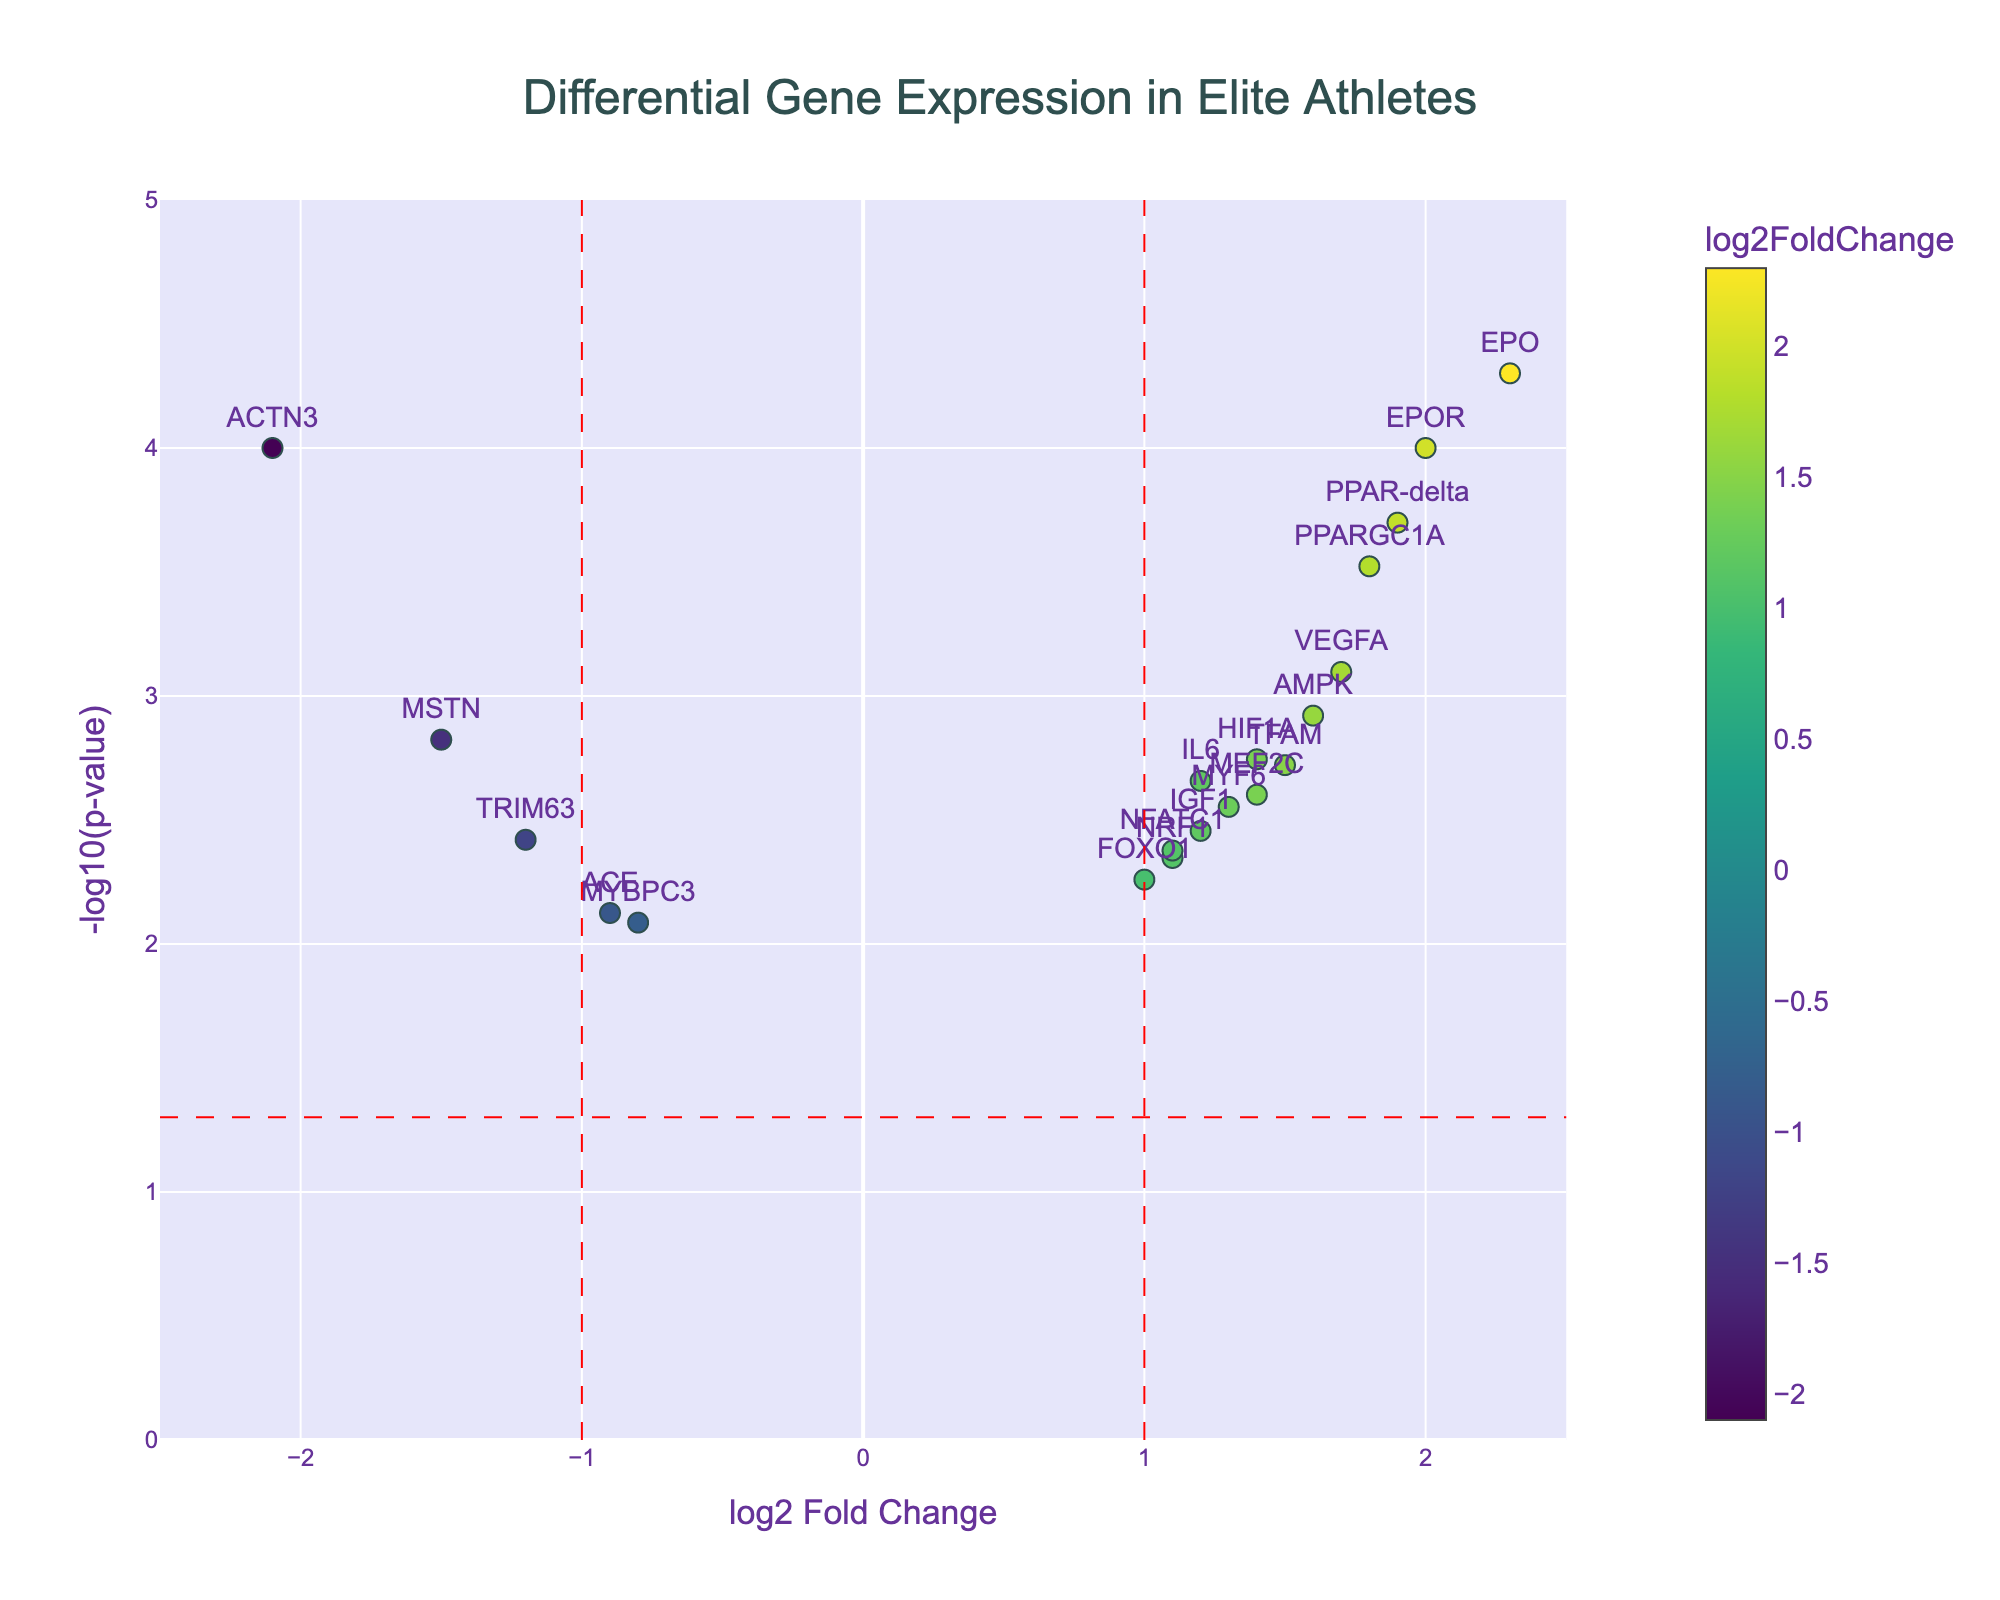What is the title of the plot? The title of the plot is located at the top and provides an overview of what the plot is about. This specific plot title is "Differential Gene Expression in Elite Athletes."
Answer: Differential Gene Expression in Elite Athletes How many genes show a significant increase in expression (log2FoldChange > 1 and p-value < 0.05)? To determine this, look at where the points fall on the plot. Genes that meet the criteria will be on the right of the log2FoldChange > 1 vertical red line and above the horizontal line representing p-value < 0.05 (which corresponds to -log10(0.05)). From the plot, these are PPARGC1A, VEGFA, EPO, HIF1A, AMPK, TFAM, PPAR-delta, and EPOR. This makes a total of 8 genes.
Answer: 8 Which gene shows the highest fold increase in expression? To find this, identify the gene with the highest log2FoldChange value on the right of the plot. The gene with the highest value is EPO with a log2FoldChange of 2.3.
Answer: EPO What is the log2FoldChange and p-value of the PPARGC1A gene? From the plot, locate the point and text annotation for PPARGC1A. It shows a log2FoldChange of 1.8 and a p-value of 0.0003.
Answer: log2FoldChange: 1.8, p-value: 0.0003 Are there any genes with reduced expression (log2FoldChange < -1 and p-value < 0.05)? If so, name one. Reduced expression genes will be to the left of the log2FoldChange < -1 vertical red line and above the horizontal line representing p-value < 0.05 (which corresponds to -log10(0.05)). The genes that meet this criteria are ACTN3 and MSTN.
Answer: ACTN3 (also MSTN) Which gene has a lower -log10(p-value), MYF6 or MEF2C? To answer this, compare the vertical positions of the points for MYF6 and MEF2C. MYF6 has a -log10(p-value) value of less than MEF2C.
Answer: MYF6 What is the range of log2FoldChange values shown on the x-axis? By looking at the x-axis, note the minimum and maximum values labeled for log2FoldChange. The range shown is from -2.5 to 2.5.
Answer: -2.5 to 2.5 Is the p-value of PPAR-delta higher or lower than 0.0005? Identify the point for PPAR-delta and check its vertical position in relation to the -log10(p-value) = -log10(0.0005) line. PPAR-delta has a p-value of 0.0002, which is lower than 0.0005.
Answer: Lower Which gene has a fold change closest to zero? Look at the points near the log2FoldChange value of zero and identify the gene closest to this value. ACE with a log2FoldChange of -0.9 is closest to zero.
Answer: ACE What is the log2FoldChange for VEGFA? Find VEGFA on the plot and look at its horizontal position to determine its log2FoldChange value. VEGFA has a log2FoldChange of 1.7.
Answer: 1.7 